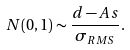Convert formula to latex. <formula><loc_0><loc_0><loc_500><loc_500>N ( 0 , 1 ) \sim \frac { d - A s } { \sigma _ { R M S } } .</formula> 